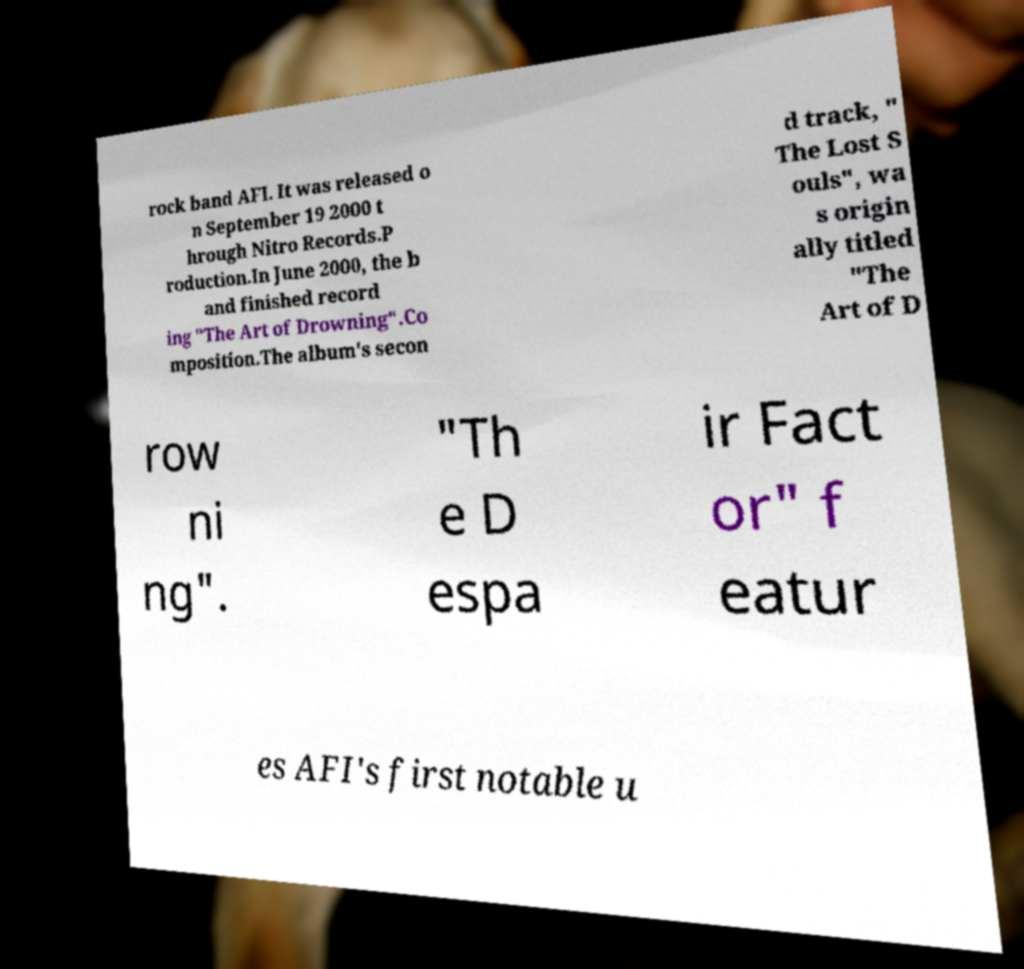What messages or text are displayed in this image? I need them in a readable, typed format. rock band AFI. It was released o n September 19 2000 t hrough Nitro Records.P roduction.In June 2000, the b and finished record ing "The Art of Drowning".Co mposition.The album's secon d track, " The Lost S ouls", wa s origin ally titled "The Art of D row ni ng". "Th e D espa ir Fact or" f eatur es AFI's first notable u 